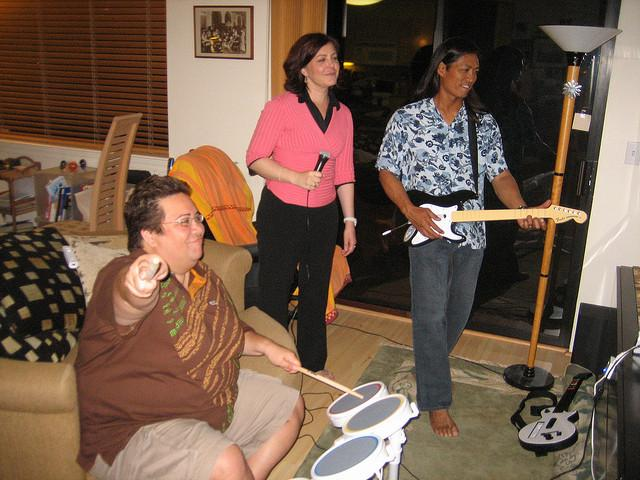What activity is being shared by the people? Please explain your reasoning. video gaming. They are holding musical instruments and a microphone and are looking at a screen. karaoke types the words to a song for sing along purposes. 